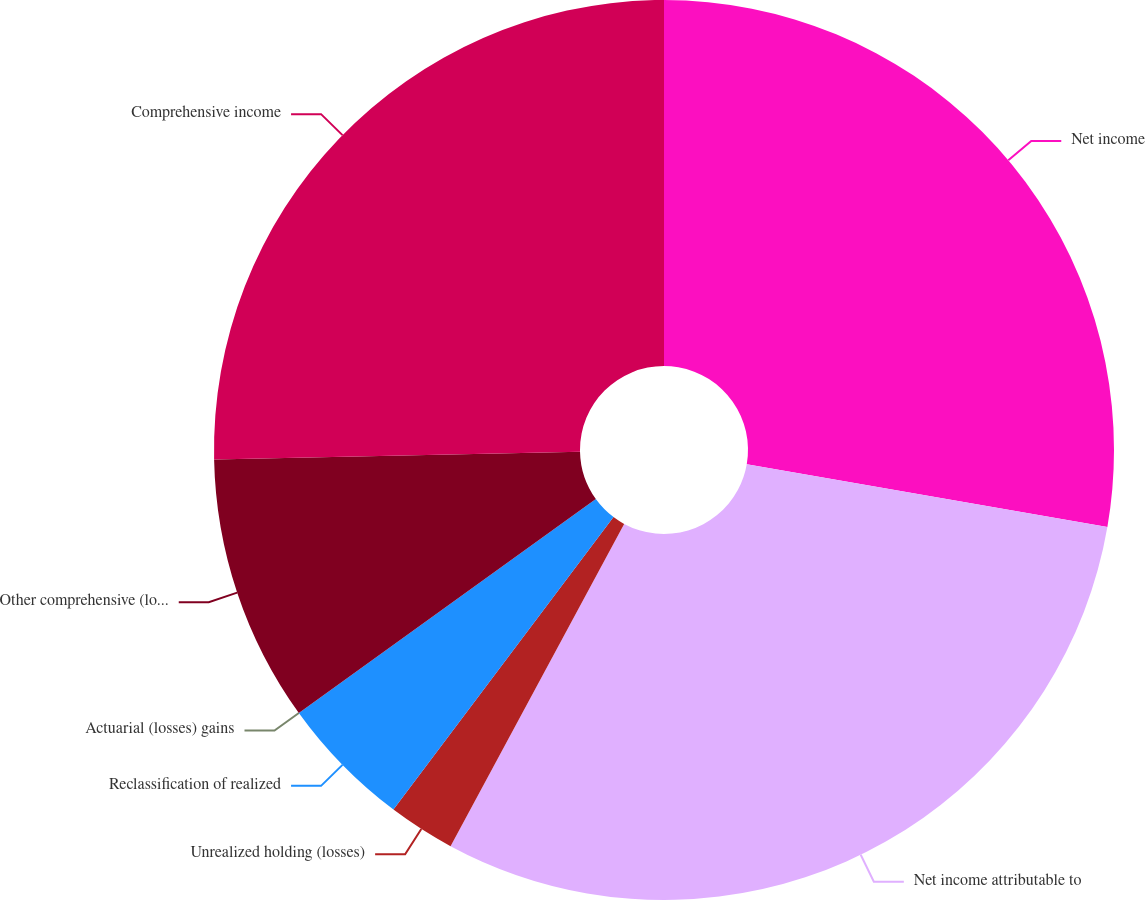<chart> <loc_0><loc_0><loc_500><loc_500><pie_chart><fcel>Net income<fcel>Net income attributable to<fcel>Unrealized holding (losses)<fcel>Reclassification of realized<fcel>Actuarial (losses) gains<fcel>Other comprehensive (loss)<fcel>Comprehensive income<nl><fcel>27.73%<fcel>30.13%<fcel>2.4%<fcel>4.8%<fcel>0.0%<fcel>9.6%<fcel>25.33%<nl></chart> 